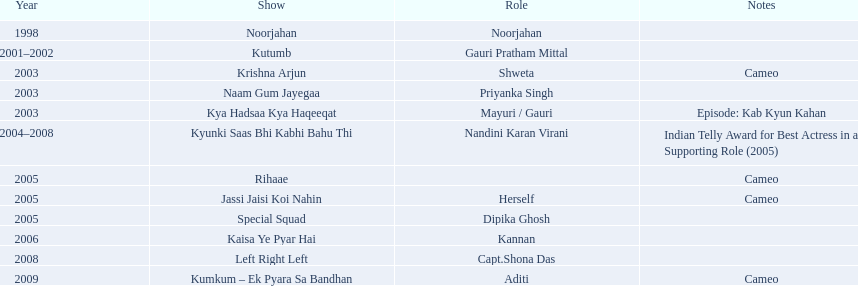In which series did gauri pradhan tejwani feature? Noorjahan, Kutumb, Krishna Arjun, Naam Gum Jayegaa, Kya Hadsaa Kya Haqeeqat, Kyunki Saas Bhi Kabhi Bahu Thi, Rihaae, Jassi Jaisi Koi Nahin, Special Squad, Kaisa Ye Pyar Hai, Left Right Left, Kumkum – Ek Pyara Sa Bandhan. Of these, which were brief roles? Krishna Arjun, Rihaae, Jassi Jaisi Koi Nahin, Kumkum – Ek Pyara Sa Bandhan. Of these, in which did she act as herself? Jassi Jaisi Koi Nahin. 